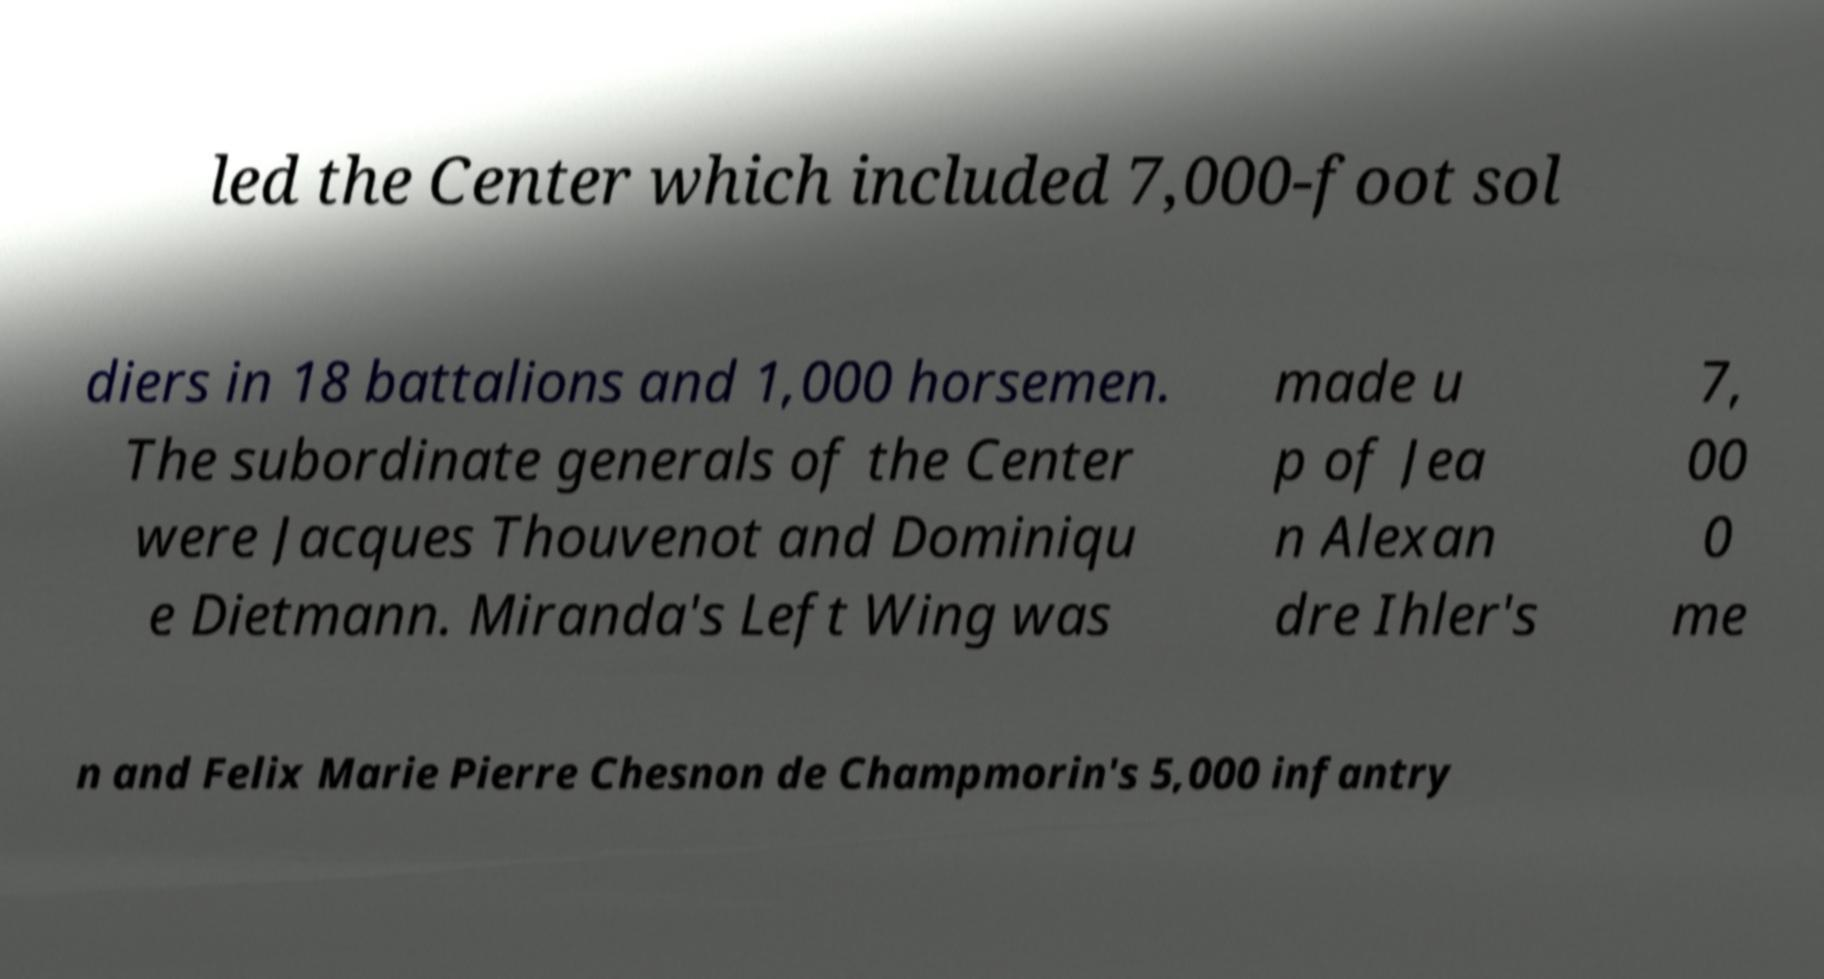What messages or text are displayed in this image? I need them in a readable, typed format. led the Center which included 7,000-foot sol diers in 18 battalions and 1,000 horsemen. The subordinate generals of the Center were Jacques Thouvenot and Dominiqu e Dietmann. Miranda's Left Wing was made u p of Jea n Alexan dre Ihler's 7, 00 0 me n and Felix Marie Pierre Chesnon de Champmorin's 5,000 infantry 